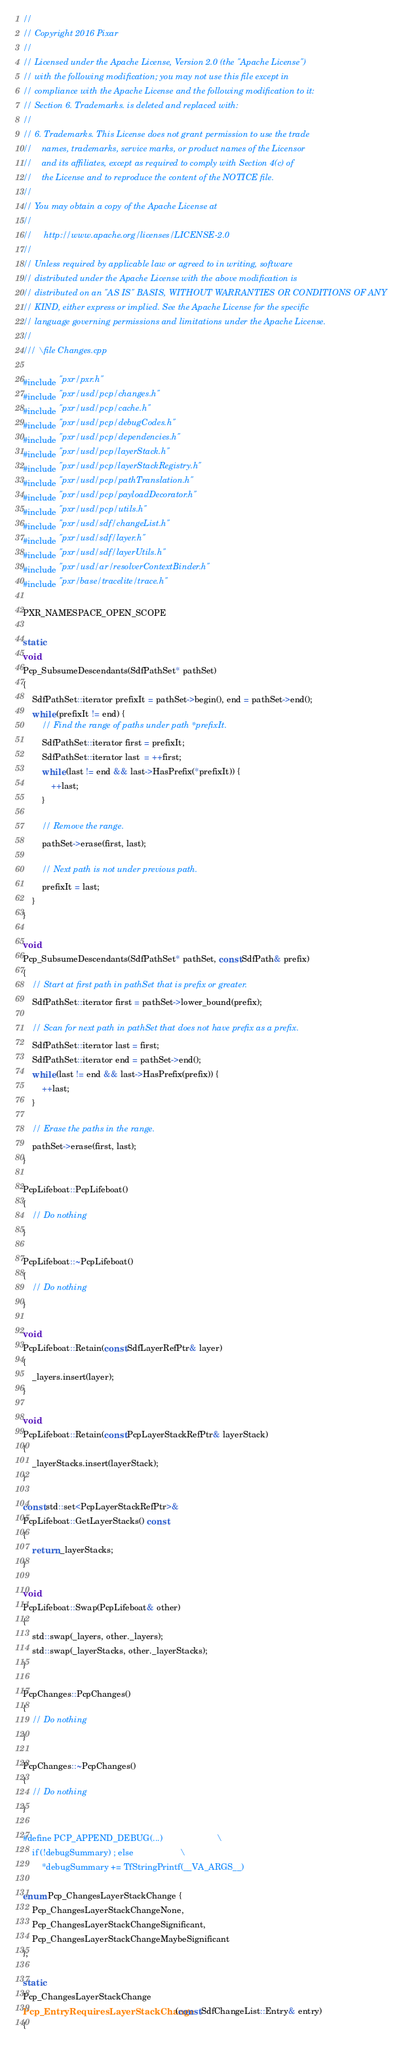Convert code to text. <code><loc_0><loc_0><loc_500><loc_500><_C++_>//
// Copyright 2016 Pixar
//
// Licensed under the Apache License, Version 2.0 (the "Apache License")
// with the following modification; you may not use this file except in
// compliance with the Apache License and the following modification to it:
// Section 6. Trademarks. is deleted and replaced with:
//
// 6. Trademarks. This License does not grant permission to use the trade
//    names, trademarks, service marks, or product names of the Licensor
//    and its affiliates, except as required to comply with Section 4(c) of
//    the License and to reproduce the content of the NOTICE file.
//
// You may obtain a copy of the Apache License at
//
//     http://www.apache.org/licenses/LICENSE-2.0
//
// Unless required by applicable law or agreed to in writing, software
// distributed under the Apache License with the above modification is
// distributed on an "AS IS" BASIS, WITHOUT WARRANTIES OR CONDITIONS OF ANY
// KIND, either express or implied. See the Apache License for the specific
// language governing permissions and limitations under the Apache License.
//
/// \file Changes.cpp

#include "pxr/pxr.h"
#include "pxr/usd/pcp/changes.h"
#include "pxr/usd/pcp/cache.h"
#include "pxr/usd/pcp/debugCodes.h"
#include "pxr/usd/pcp/dependencies.h"
#include "pxr/usd/pcp/layerStack.h"
#include "pxr/usd/pcp/layerStackRegistry.h"
#include "pxr/usd/pcp/pathTranslation.h"
#include "pxr/usd/pcp/payloadDecorator.h"
#include "pxr/usd/pcp/utils.h"
#include "pxr/usd/sdf/changeList.h"
#include "pxr/usd/sdf/layer.h"
#include "pxr/usd/sdf/layerUtils.h"
#include "pxr/usd/ar/resolverContextBinder.h"
#include "pxr/base/tracelite/trace.h"

PXR_NAMESPACE_OPEN_SCOPE

static
void
Pcp_SubsumeDescendants(SdfPathSet* pathSet)
{
    SdfPathSet::iterator prefixIt = pathSet->begin(), end = pathSet->end();
    while (prefixIt != end) {
        // Find the range of paths under path *prefixIt.
        SdfPathSet::iterator first = prefixIt;
        SdfPathSet::iterator last  = ++first;
        while (last != end && last->HasPrefix(*prefixIt)) {
            ++last;
        }

        // Remove the range.
        pathSet->erase(first, last);

        // Next path is not under previous path.
        prefixIt = last;
    }
}

void
Pcp_SubsumeDescendants(SdfPathSet* pathSet, const SdfPath& prefix)
{
    // Start at first path in pathSet that is prefix or greater.
    SdfPathSet::iterator first = pathSet->lower_bound(prefix); 

    // Scan for next path in pathSet that does not have prefix as a prefix.
    SdfPathSet::iterator last = first;
    SdfPathSet::iterator end = pathSet->end();
    while (last != end && last->HasPrefix(prefix)) {
        ++last;
    }

    // Erase the paths in the range.
    pathSet->erase(first, last);
}

PcpLifeboat::PcpLifeboat()
{
    // Do nothing
}

PcpLifeboat::~PcpLifeboat()
{
    // Do nothing
}

void
PcpLifeboat::Retain(const SdfLayerRefPtr& layer)
{
    _layers.insert(layer);
}

void
PcpLifeboat::Retain(const PcpLayerStackRefPtr& layerStack)
{
    _layerStacks.insert(layerStack);
}

const std::set<PcpLayerStackRefPtr>& 
PcpLifeboat::GetLayerStacks() const
{
    return _layerStacks;
}

void
PcpLifeboat::Swap(PcpLifeboat& other)
{
    std::swap(_layers, other._layers);
    std::swap(_layerStacks, other._layerStacks);
}

PcpChanges::PcpChanges()
{
    // Do nothing
}

PcpChanges::~PcpChanges()
{
    // Do nothing
}

#define PCP_APPEND_DEBUG(...)                       \
    if (!debugSummary) ; else                    \
        *debugSummary += TfStringPrintf(__VA_ARGS__)

enum Pcp_ChangesLayerStackChange {
    Pcp_ChangesLayerStackChangeNone,
    Pcp_ChangesLayerStackChangeSignificant,
    Pcp_ChangesLayerStackChangeMaybeSignificant
};

static
Pcp_ChangesLayerStackChange
Pcp_EntryRequiresLayerStackChange(const SdfChangeList::Entry& entry)
{</code> 